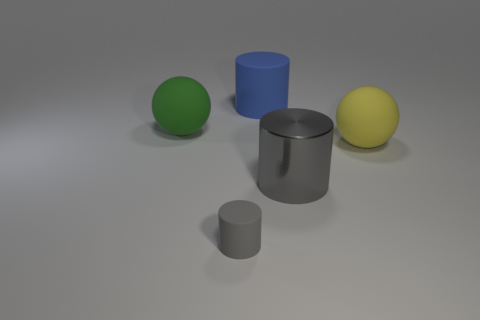Add 4 blue matte objects. How many objects exist? 9 Subtract all cylinders. How many objects are left? 2 Subtract all gray metal cylinders. Subtract all big blue objects. How many objects are left? 3 Add 1 metallic objects. How many metallic objects are left? 2 Add 4 tiny balls. How many tiny balls exist? 4 Subtract 0 blue balls. How many objects are left? 5 